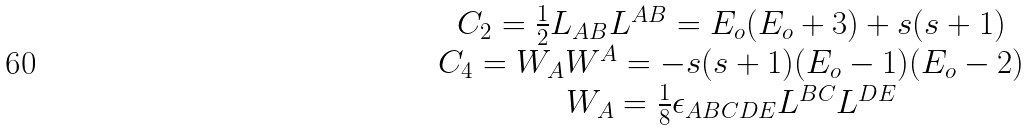<formula> <loc_0><loc_0><loc_500><loc_500>\begin{array} { c } { { C _ { 2 } = \frac { 1 } { 2 } L _ { A B } L ^ { A B } = E _ { o } ( E _ { o } + 3 ) + s ( s + 1 ) } } \\ { { C _ { 4 } = W _ { A } W ^ { A } = - s ( s + 1 ) ( E _ { o } - 1 ) ( E _ { o } - 2 ) } } \\ { { W _ { A } = \frac { 1 } { 8 } \epsilon _ { A B C D E } L ^ { B C } L ^ { D E } } } \end{array}</formula> 